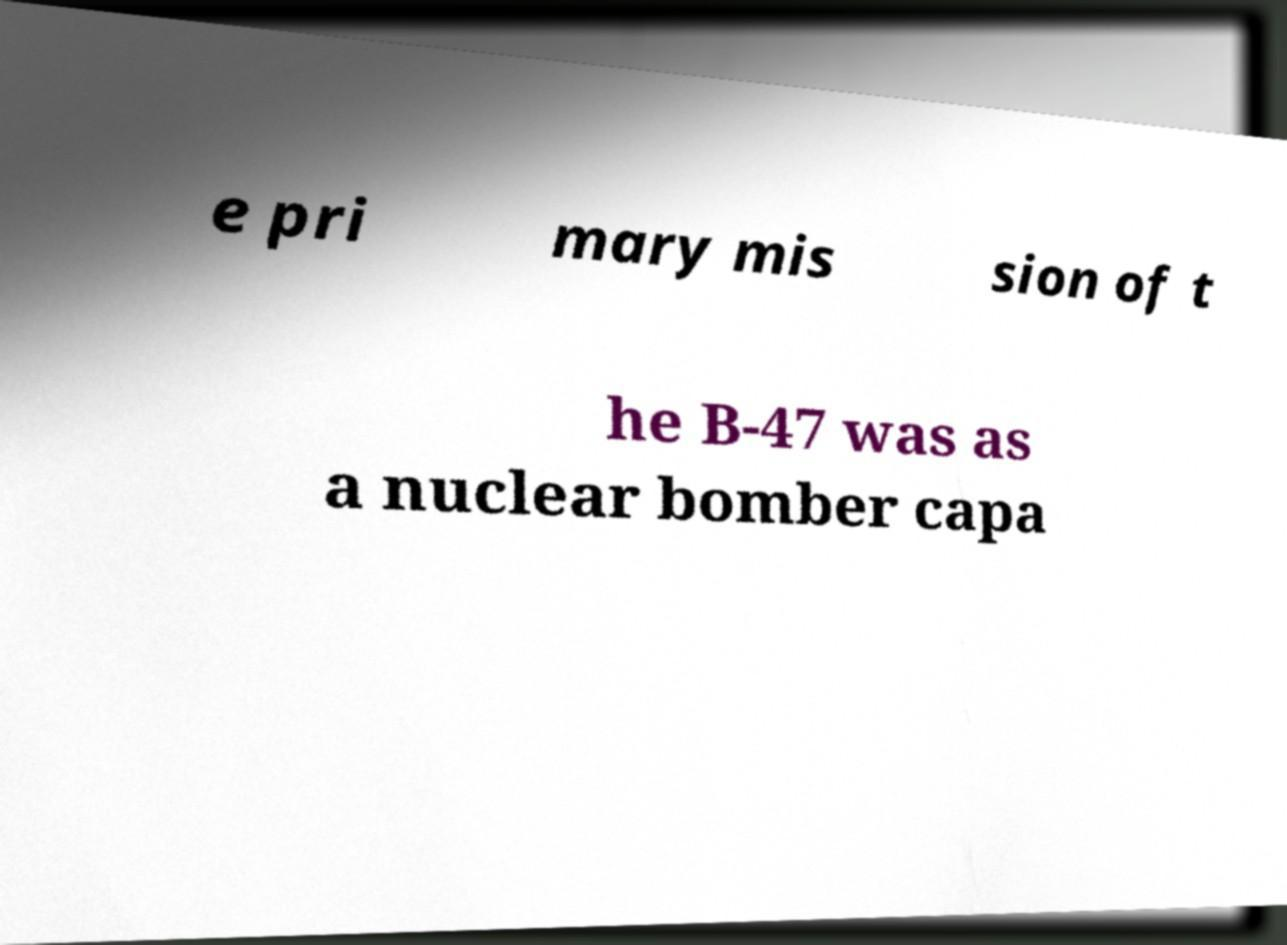Can you accurately transcribe the text from the provided image for me? e pri mary mis sion of t he B-47 was as a nuclear bomber capa 